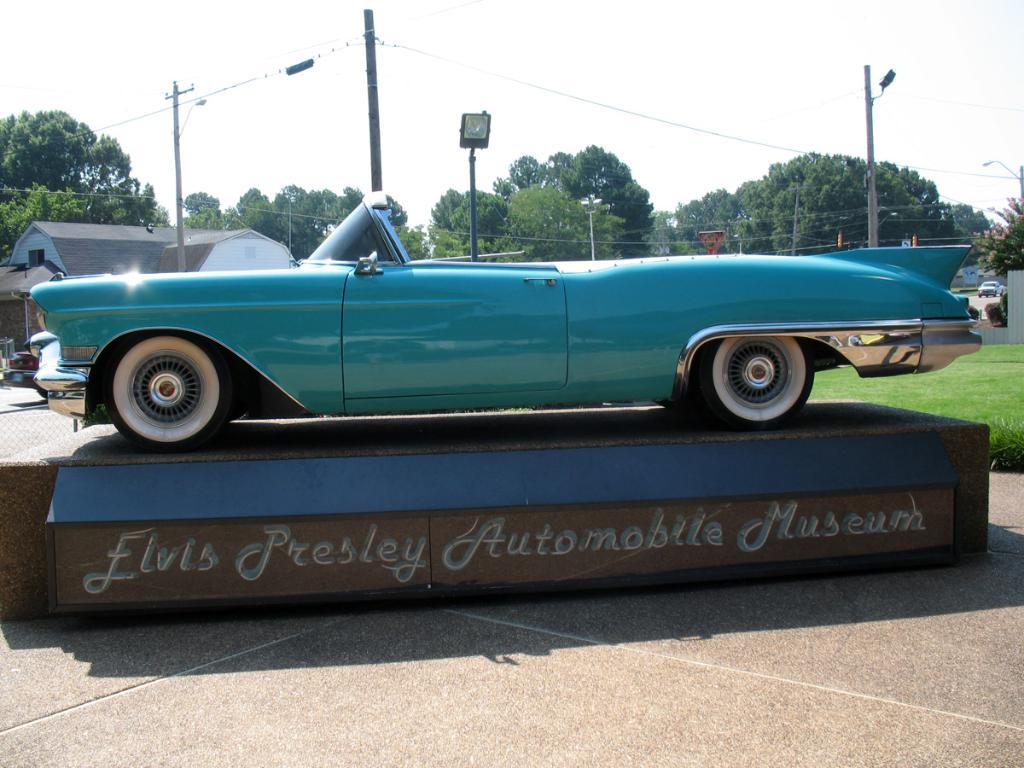What is the main subject of the image? There is a vehicle parked on a stage in the image. How is the stage positioned in relation to the ground? The stage is placed on the ground. What can be seen in the background of the image? There is a group of police, buildings, trees, and the sky visible in the background of the image. What type of animal is laughing and marking its territory in the image? There are no animals present in the image, let alone one that is laughing and marking marking its territory. 